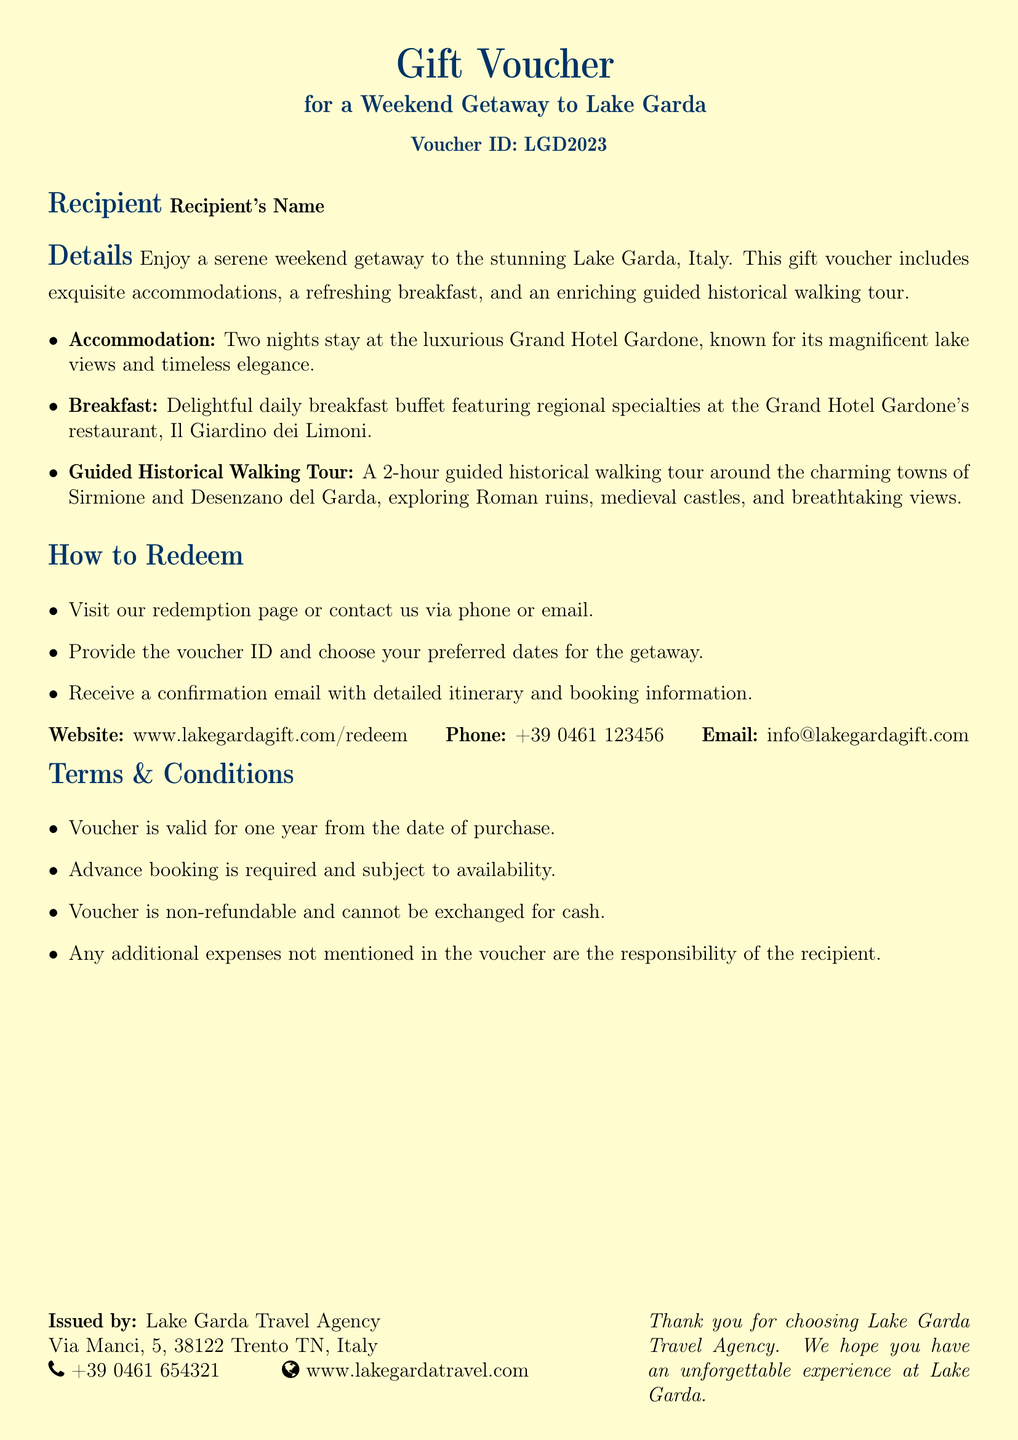What is the voucher ID? The voucher ID is explicitly stated in the document.
Answer: LGD2023 How long is the accommodation for? The document specifies the duration of the stay provided in the details.
Answer: Two nights Where is the breakfast served? The location of the breakfast is mentioned in the accommodation details.
Answer: Il Giardino dei Limoni What attractions will the walking tour cover? The document lists the specific towns and attractions included in the walking tour.
Answer: Sirmione and Desenzano del Garda How can the voucher be redeemed? The document outlines the steps necessary for redeeming the voucher.
Answer: Visit redemption page or contact via phone or email What is the validity period of the voucher? The validity period is mentioned under the terms and conditions section of the document.
Answer: One year What type of tour is included? The type of tour is defined in the details of the voucher.
Answer: Guided historical walking tour What must be done in advance for the stay? The document specifies a requirement that must be fulfilled prior to booking.
Answer: Advance booking is required 